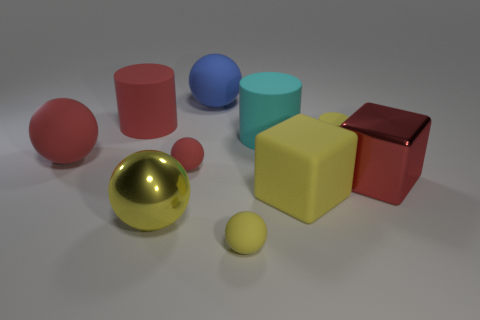What number of green things are either big shiny blocks or small balls?
Provide a short and direct response. 0. What is the shape of the small yellow rubber object that is to the left of the tiny yellow thing that is behind the large yellow metal ball?
Make the answer very short. Sphere. Does the yellow object behind the metallic cube have the same size as the matte ball that is in front of the large rubber cube?
Your answer should be compact. Yes. Are there any large yellow things made of the same material as the blue thing?
Give a very brief answer. Yes. What is the size of the block that is the same color as the shiny ball?
Give a very brief answer. Large. Are there any tiny yellow rubber things in front of the large red object on the right side of the small yellow object behind the large metallic ball?
Make the answer very short. Yes. Are there any red blocks in front of the big red cube?
Offer a very short reply. No. How many big yellow rubber cubes are behind the tiny rubber cylinder that is in front of the large red rubber cylinder?
Your answer should be very brief. 0. There is a blue sphere; is it the same size as the metallic cube in front of the large red matte ball?
Your answer should be compact. Yes. Is there a tiny matte ball that has the same color as the tiny cylinder?
Your answer should be compact. Yes. 